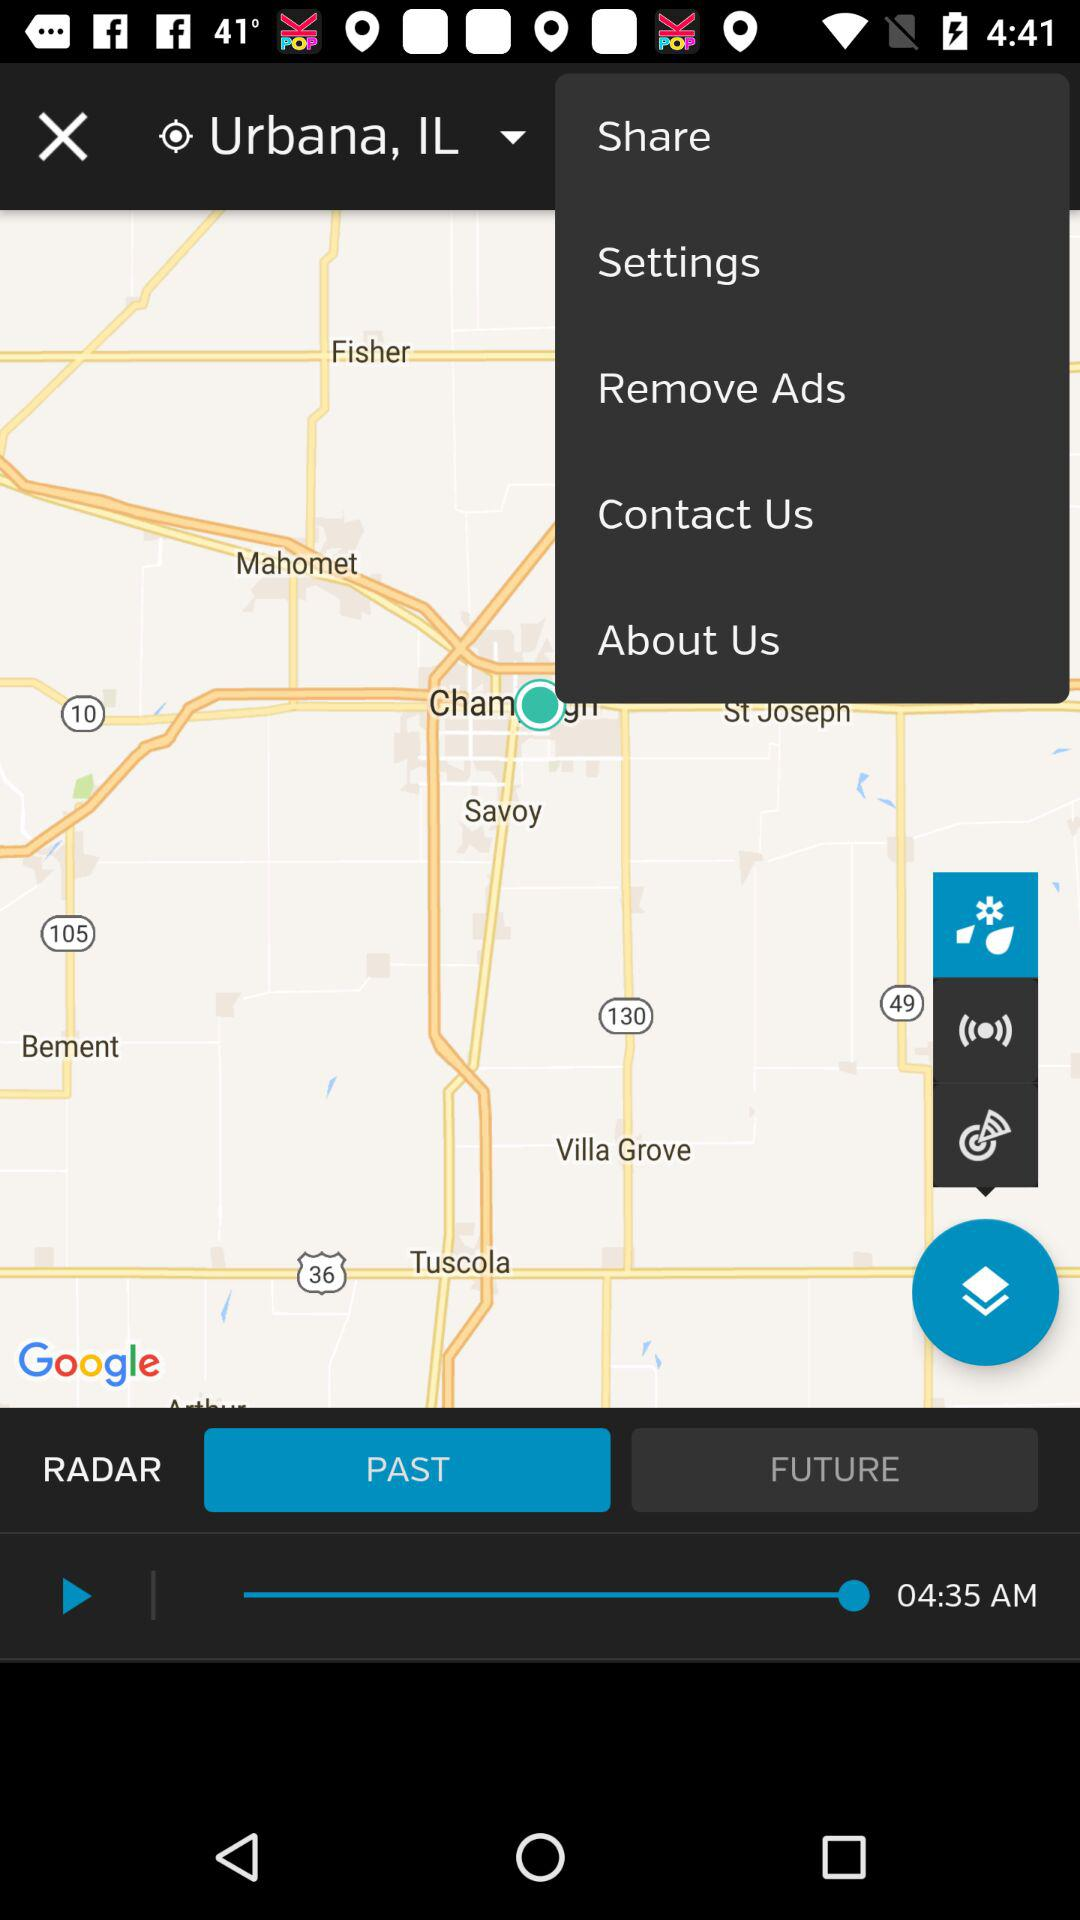What is the total duration?
When the provided information is insufficient, respond with <no answer>. <no answer> 